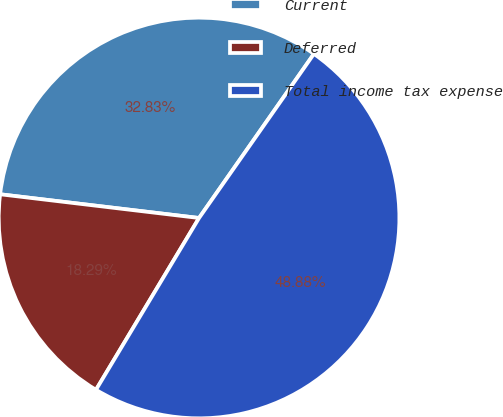Convert chart to OTSL. <chart><loc_0><loc_0><loc_500><loc_500><pie_chart><fcel>Current<fcel>Deferred<fcel>Total income tax expense<nl><fcel>32.83%<fcel>18.29%<fcel>48.88%<nl></chart> 